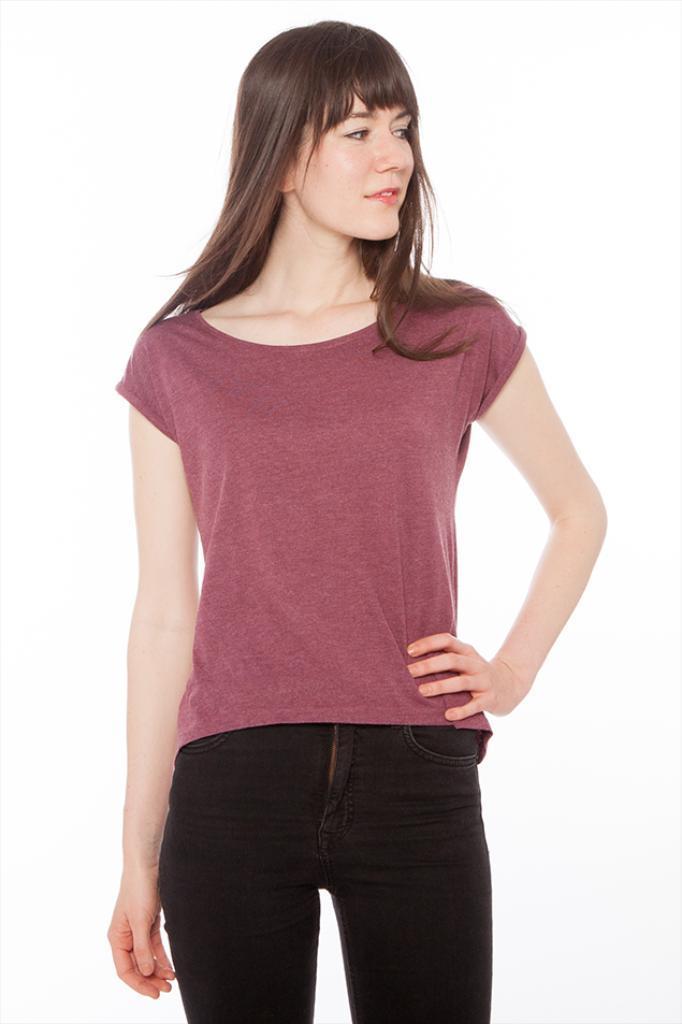Could you give a brief overview of what you see in this image? In this image we can see a woman standing and the background is white. 